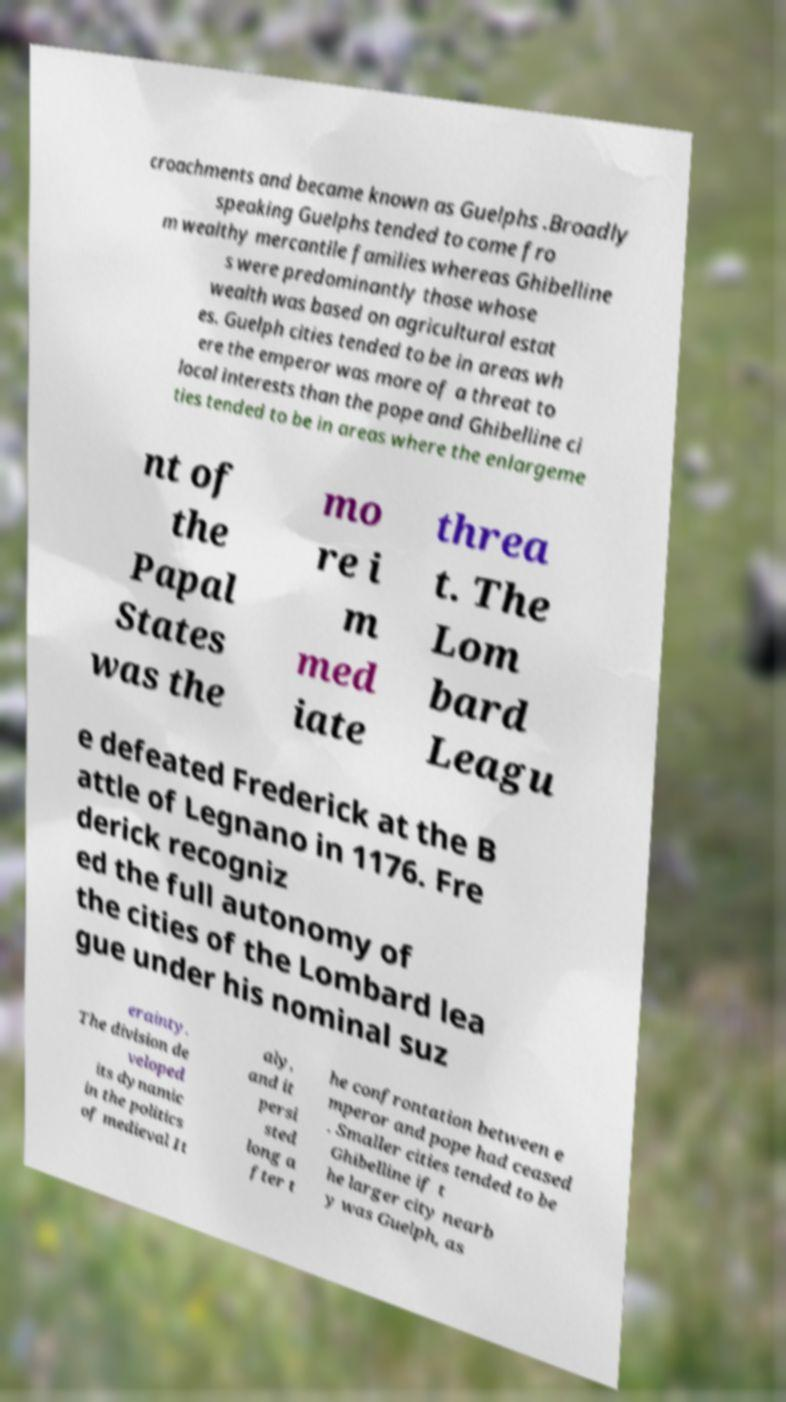There's text embedded in this image that I need extracted. Can you transcribe it verbatim? croachments and became known as Guelphs .Broadly speaking Guelphs tended to come fro m wealthy mercantile families whereas Ghibelline s were predominantly those whose wealth was based on agricultural estat es. Guelph cities tended to be in areas wh ere the emperor was more of a threat to local interests than the pope and Ghibelline ci ties tended to be in areas where the enlargeme nt of the Papal States was the mo re i m med iate threa t. The Lom bard Leagu e defeated Frederick at the B attle of Legnano in 1176. Fre derick recogniz ed the full autonomy of the cities of the Lombard lea gue under his nominal suz erainty. The division de veloped its dynamic in the politics of medieval It aly, and it persi sted long a fter t he confrontation between e mperor and pope had ceased . Smaller cities tended to be Ghibelline if t he larger city nearb y was Guelph, as 